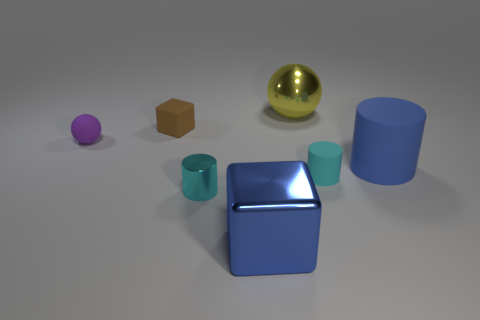Is the number of large metallic spheres left of the blue block less than the number of tiny rubber objects that are in front of the large matte cylinder?
Your answer should be compact. Yes. What is the color of the small shiny object?
Your response must be concise. Cyan. Is there another small cylinder of the same color as the small metal cylinder?
Make the answer very short. Yes. What is the shape of the object behind the matte object that is behind the small purple rubber object that is on the left side of the cyan matte cylinder?
Provide a succinct answer. Sphere. There is a thing that is behind the tiny brown rubber thing; what is it made of?
Ensure brevity in your answer.  Metal. What is the size of the cyan object that is behind the cyan thing that is in front of the cyan object on the right side of the big blue block?
Offer a very short reply. Small. There is a purple thing; does it have the same size as the cyan object to the right of the yellow metallic object?
Offer a terse response. Yes. There is a big metal thing that is behind the purple rubber object; what is its color?
Offer a terse response. Yellow. There is a rubber object that is the same color as the shiny cube; what shape is it?
Your answer should be compact. Cylinder. The small cyan thing that is to the right of the blue block has what shape?
Keep it short and to the point. Cylinder. 